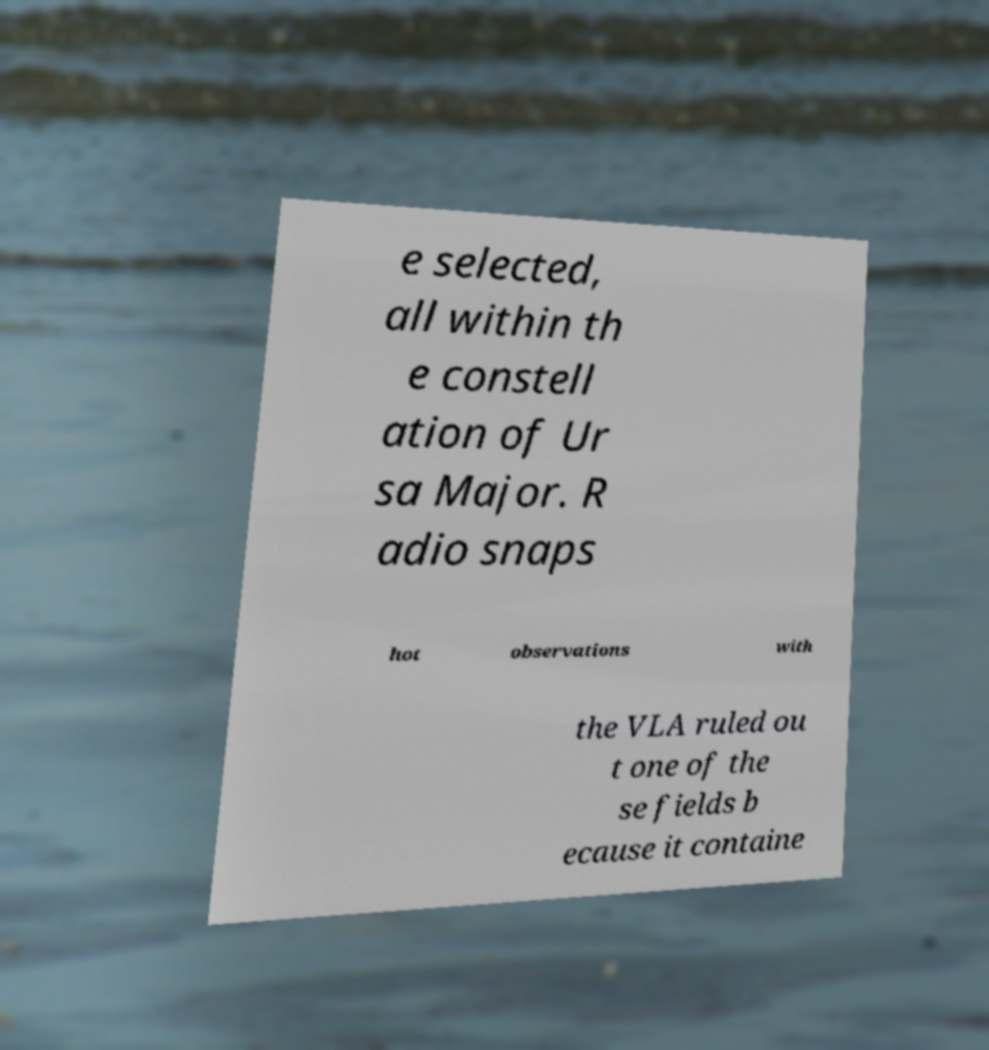Could you assist in decoding the text presented in this image and type it out clearly? e selected, all within th e constell ation of Ur sa Major. R adio snaps hot observations with the VLA ruled ou t one of the se fields b ecause it containe 